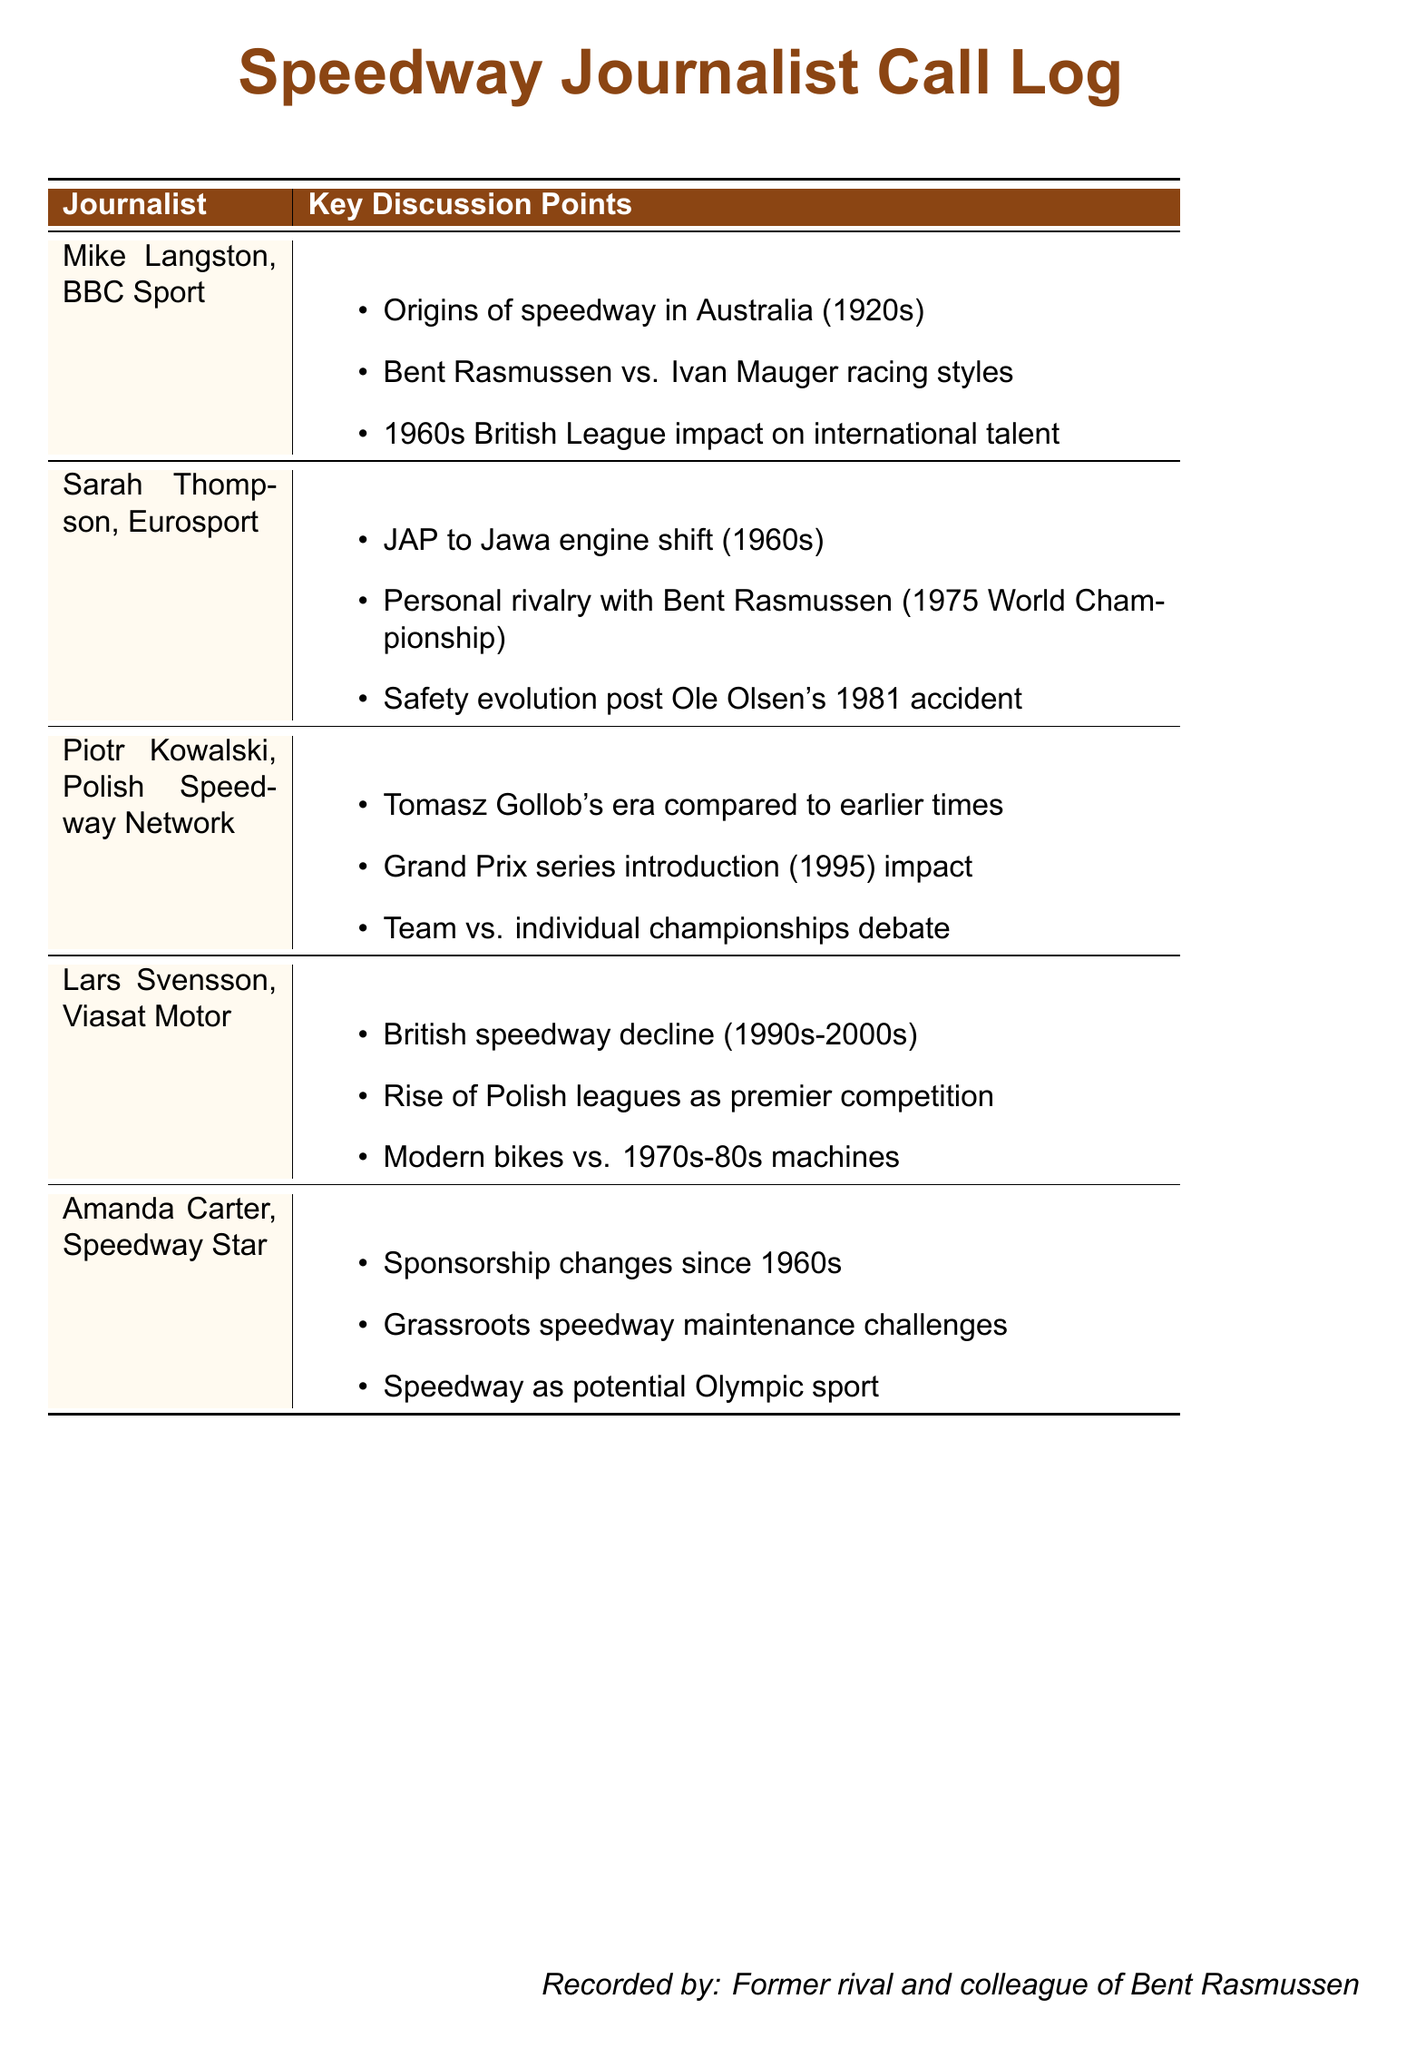What is the name of the journalist from BBC Sport? The name of the journalist from BBC Sport is mentioned in the document under the relevant section.
Answer: Mike Langston What key discussion point is associated with Sarah Thompson? The document lists multiple key discussion points, and one is specifically associated with Sarah Thompson.
Answer: Personal rivalry with Bent Rasmussen (1975 World Championship) What era is compared with Tomasz Gollob's in the document? The document refers to Tomasz Gollob's era in comparison with earlier times in speedway history.
Answer: Earlier times Which league is noted for its decline in the 1990s-2000s? The document explicitly states which league experienced a decline during that period.
Answer: British speedway What engine shift is highlighted in the document? The transition from one engine type to another is mentioned in relation to the 1960s.
Answer: JAP to Jawa engine shift (1960s) In what year was the Grand Prix series introduced? The Grand Prix series introduction year is clearly stated in the document.
Answer: 1995 What issue does Amanda Carter discuss regarding grassroots speedway? The document specifies a particular challenge related to grassroots speedway mentioned by Amanda Carter.
Answer: Maintenance challenges What is the profession of the person who recorded the calls? The document identifies the role of the individual who recorded the detailed discussions.
Answer: Former rival and colleague of Bent Rasmussen 